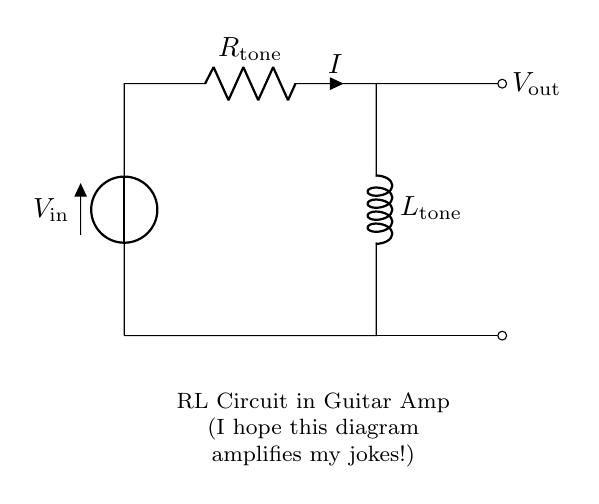What is the input voltage in the circuit? The input voltage is represented by the symbol V sub in, which is indicated at the start of the circuit diagram. It shows the voltage supplied to the circuit.
Answer: V in What type of components are in this circuit? The components visible in the circuit are a resistor and an inductor, which are indicated by the symbols R and L, respectively.
Answer: Resistor and inductor What is the purpose of the resistor in this RL circuit? The resistor is used for controlling the amount of current flowing in the circuit and affects the voltage drop across it. This helps in tone shaping for the guitar amplifier.
Answer: Tone shaping What is the relationship between current and voltage in the circuit? In an RL circuit, the current lags the voltage due to the inductor's reactance, which stores energy in a magnetic field and causes a delay.
Answer: Current lags voltage What does V out represent in this circuit? The V out symbol indicates the output voltage of the circuit, which is the voltage measured across the load resulting from the combination of the resistor and the inductor.
Answer: V out How does the inductor contribute to distortion effects? The inductor introduces reactance, which alters the waveform of the input signal, creating a distortion effect that enhances the sound qualities for the guitar amplifier.
Answer: Alters waveform 